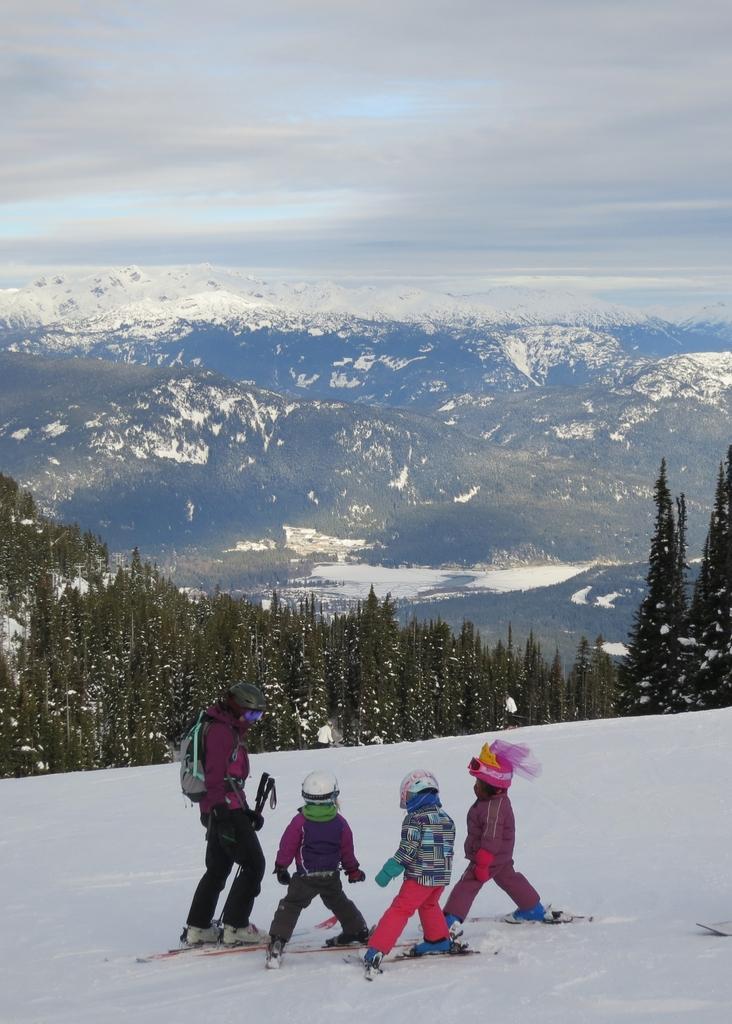Describe this image in one or two sentences. This image consists of four persons skiing. At the bottom, there is snow. In the background, there are mountains covered with snow. In the middle, there are trees. At the top, there are clouds in the sky. 